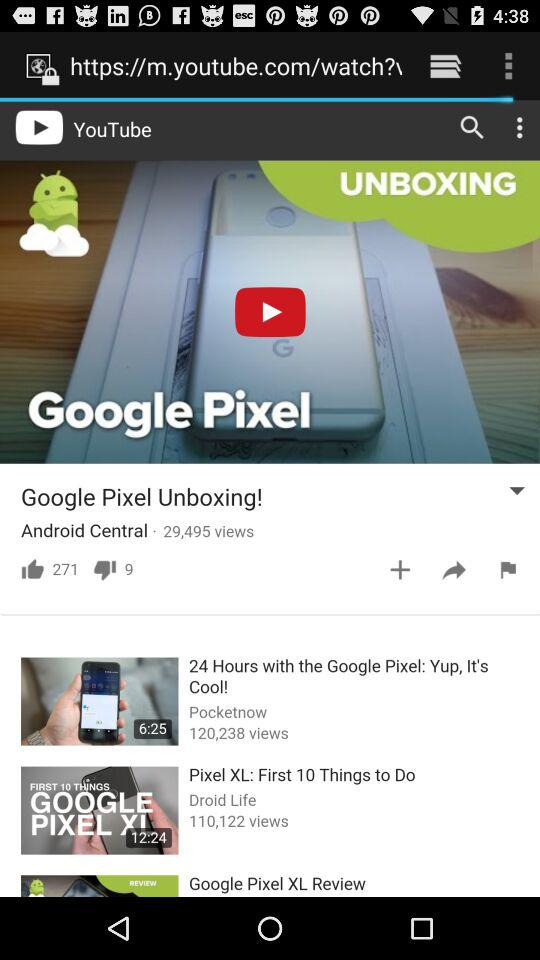What is the channel name on which "Google Pixel Unboxing!" is uploaded? The channel name is "Android Central". 